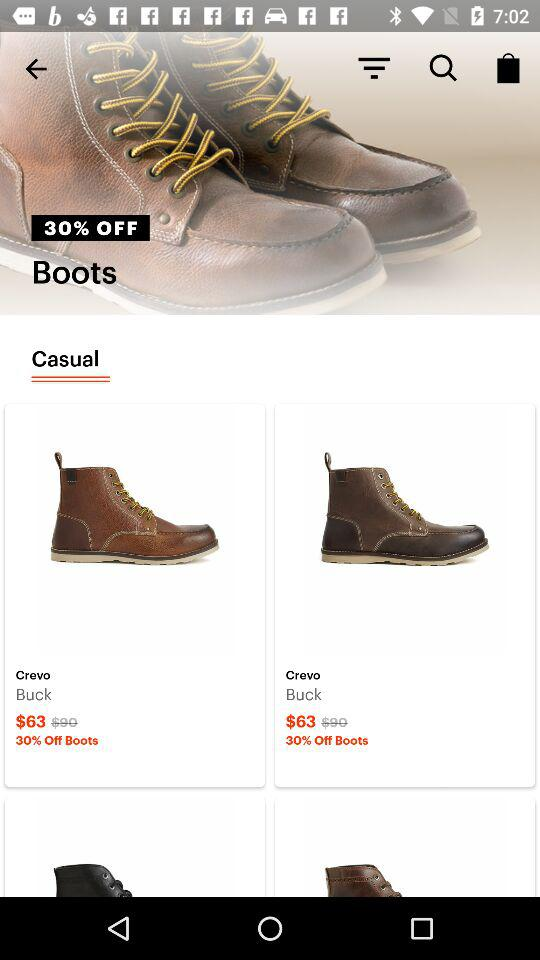What is the offer on casual boots? The offer on casual boots is 30% off. 